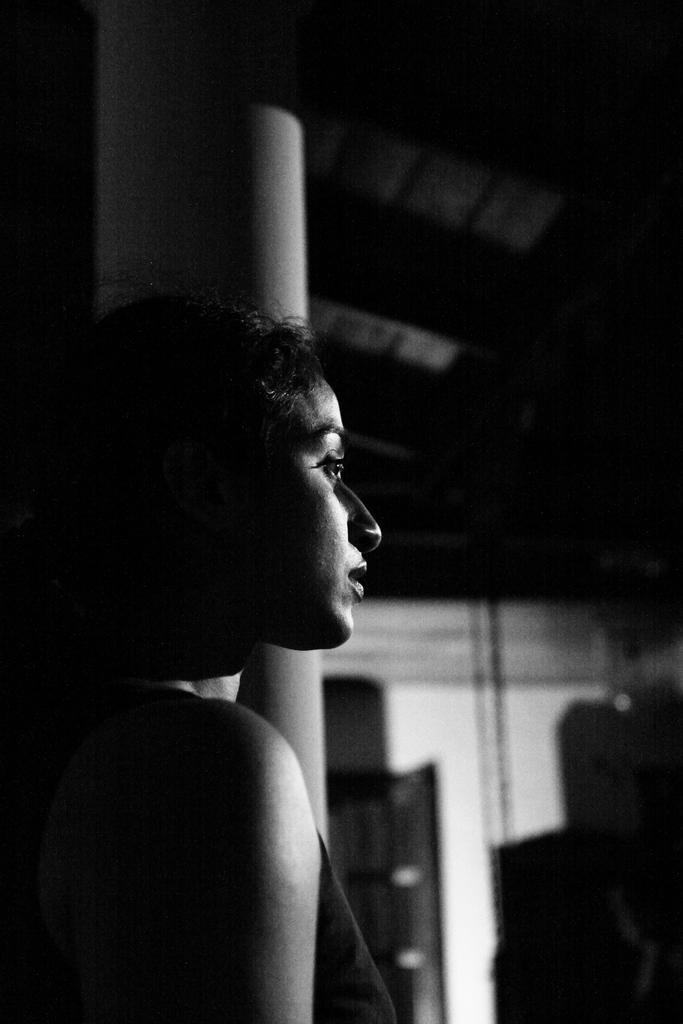Describe this image in one or two sentences. In the image in the center, we can see one person standing. In the background there is a wall, roof, door, pillar and a few other objects. 